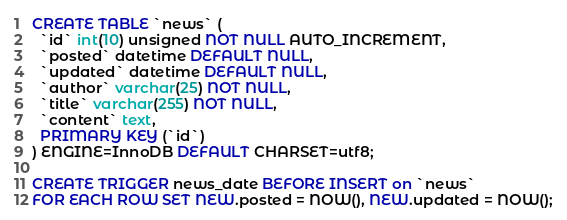Convert code to text. <code><loc_0><loc_0><loc_500><loc_500><_SQL_>CREATE TABLE `news` (
  `id` int(10) unsigned NOT NULL AUTO_INCREMENT,
  `posted` datetime DEFAULT NULL,
  `updated` datetime DEFAULT NULL,
  `author` varchar(25) NOT NULL,
  `title` varchar(255) NOT NULL,
  `content` text,
  PRIMARY KEY (`id`)
) ENGINE=InnoDB DEFAULT CHARSET=utf8;

CREATE TRIGGER news_date BEFORE INSERT on `news`
FOR EACH ROW SET NEW.posted = NOW(), NEW.updated = NOW();
</code> 